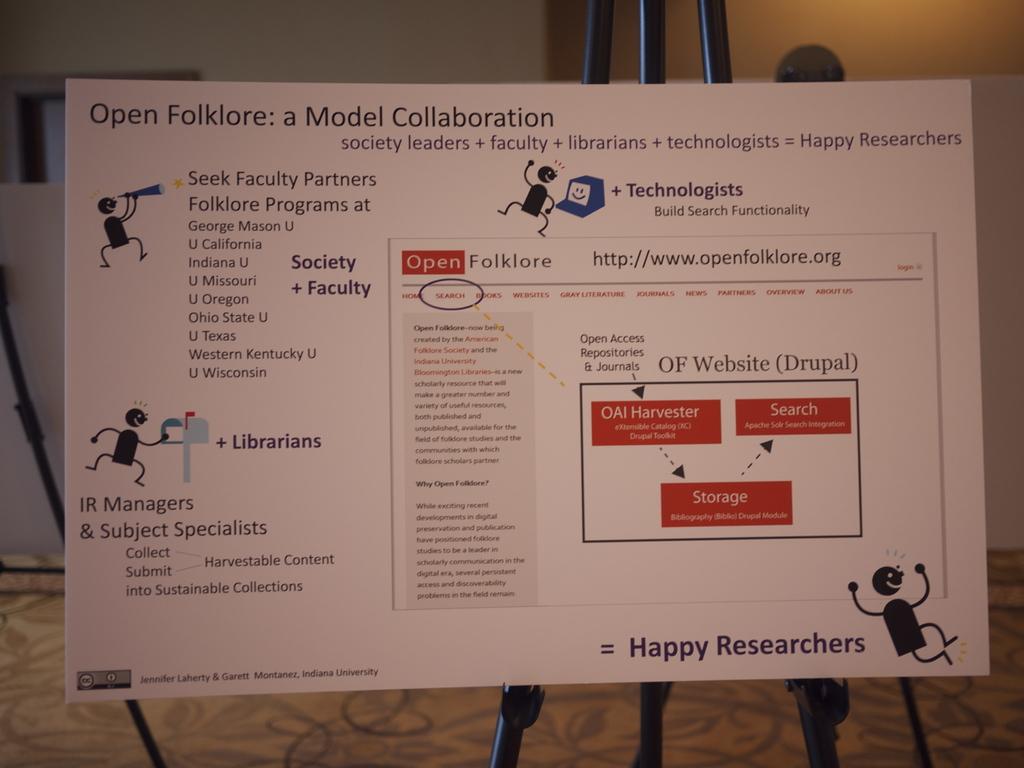What type of folklore is it?
Offer a terse response. Open. How do the researchers feel when this model is followed and applied?
Make the answer very short. Happy. 